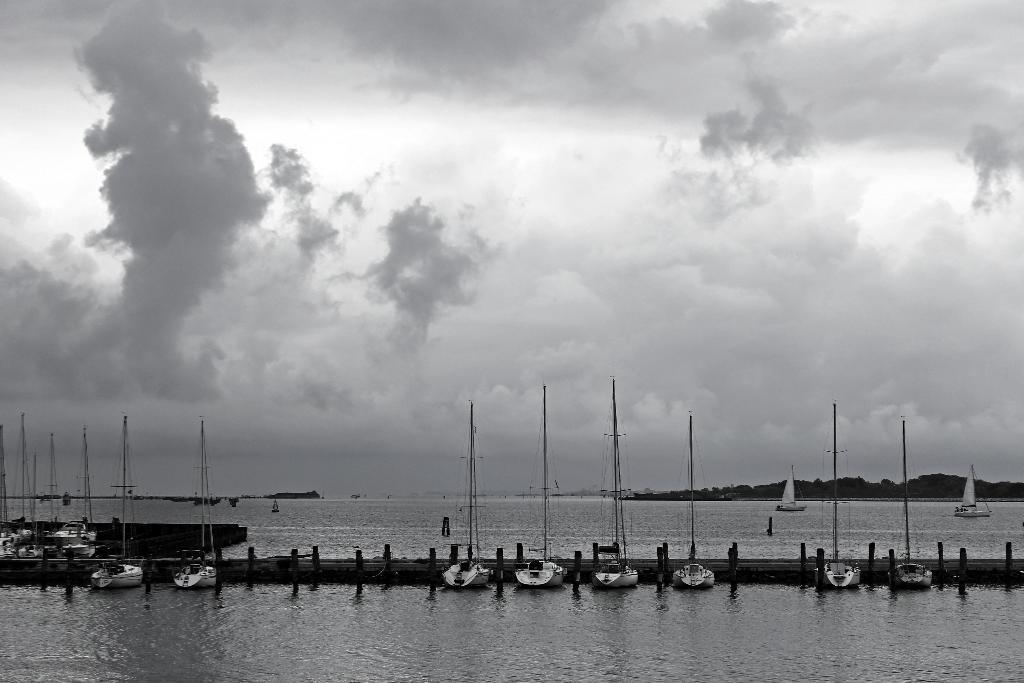Please provide a concise description of this image. In this image, we can see some water. We can see some ships, boats and some objects sailing on the water. We can also see a path above the water. There are a few hills. We can see the sky with clouds. 